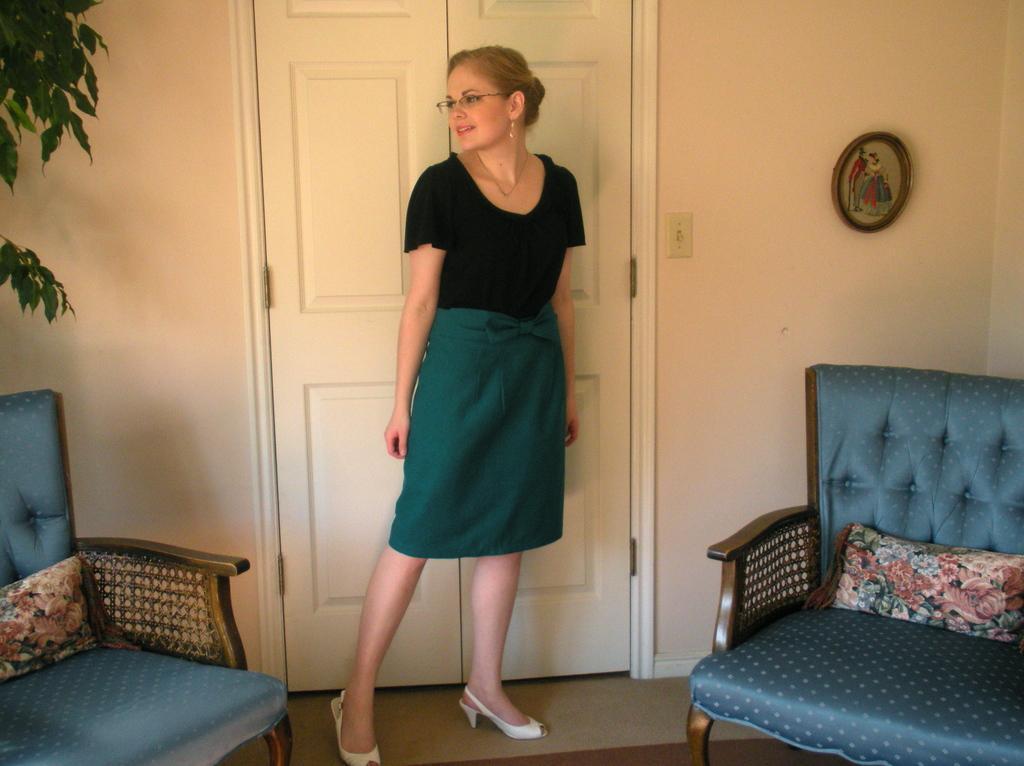In one or two sentences, can you explain what this image depicts? This image consists of a woman who is wearing black dress, she is in the middle. There are sofas on the right and left side. There is a plant on the left side. There is a door behind her. 